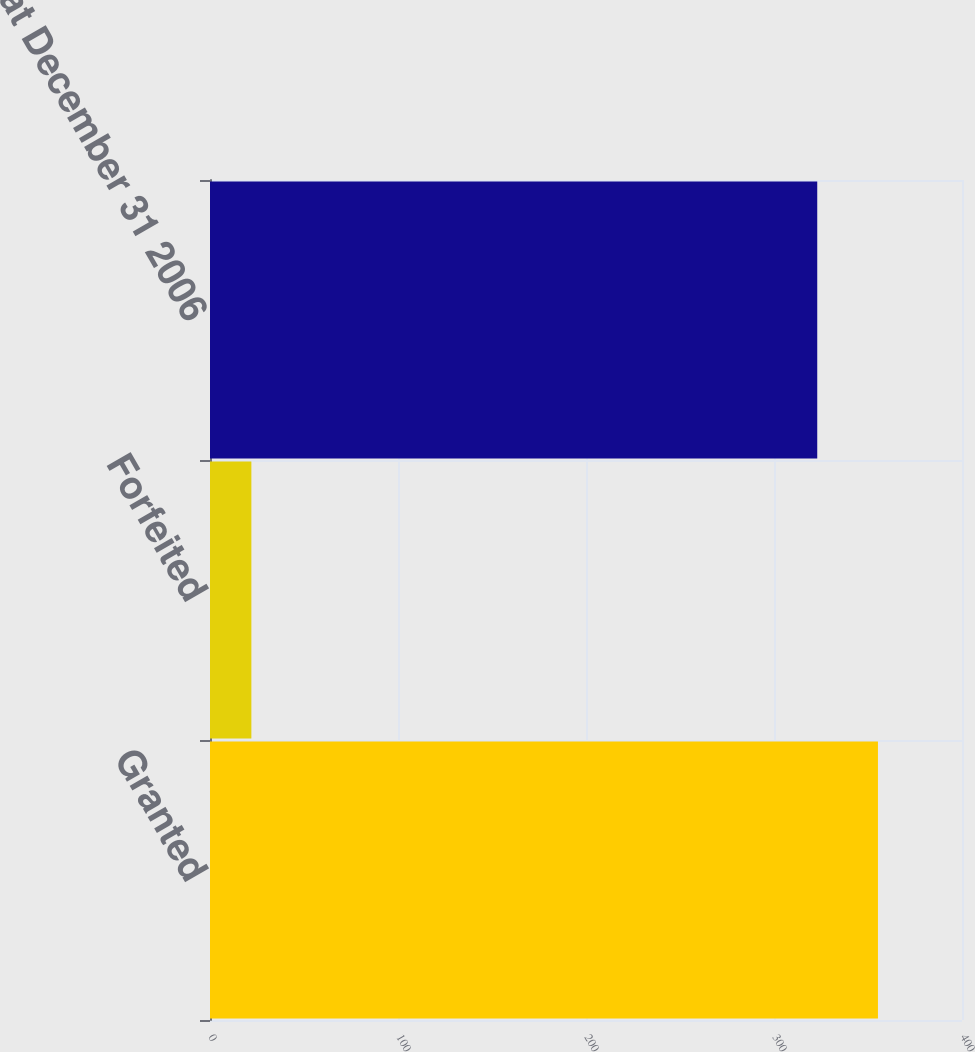Convert chart to OTSL. <chart><loc_0><loc_0><loc_500><loc_500><bar_chart><fcel>Granted<fcel>Forfeited<fcel>Nonvested at December 31 2006<nl><fcel>355.3<fcel>22<fcel>323<nl></chart> 